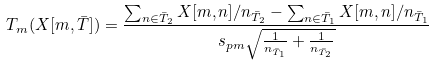<formula> <loc_0><loc_0><loc_500><loc_500>T _ { m } ( X [ m , \bar { T } ] ) = \frac { \sum _ { n \in \bar { T } _ { 2 } } X [ m , n ] / n _ { \bar { T } _ { 2 } } - \sum _ { n \in \bar { T } _ { 1 } } X [ m , n ] / n _ { \bar { T } _ { 1 } } } { s _ { p m } \sqrt { \frac { 1 } { n _ { \bar { T } _ { 1 } } } + \frac { 1 } { n _ { \bar { T } _ { 2 } } } } }</formula> 